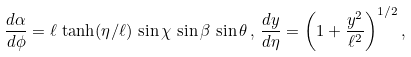Convert formula to latex. <formula><loc_0><loc_0><loc_500><loc_500>\frac { d \alpha } { d \phi } = \ell \, \tanh ( \eta / \ell ) \, \sin \chi \, \sin \beta \, \sin \theta \, , \, \frac { d y } { d \eta } = \left ( 1 + \frac { y ^ { 2 } } { \ell ^ { 2 } } \right ) ^ { 1 / 2 } ,</formula> 